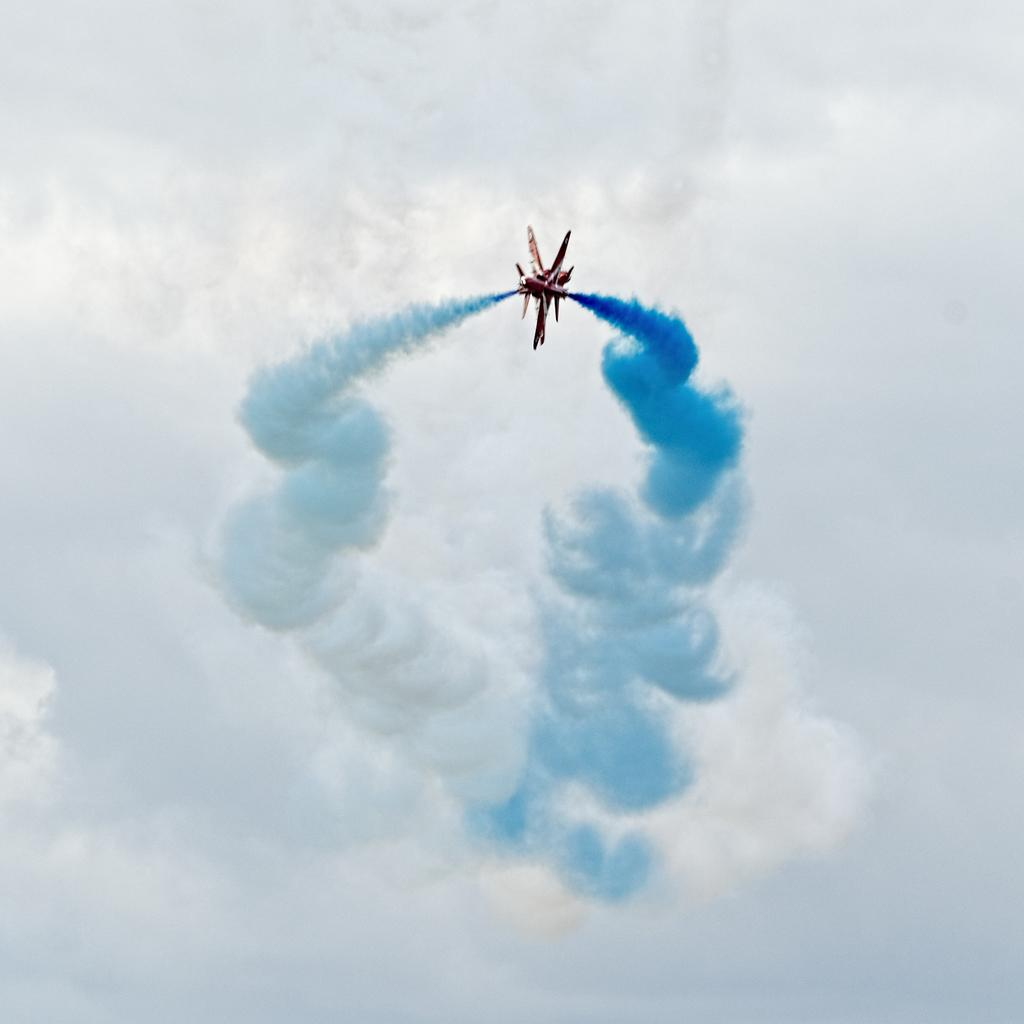What is the main subject of the image? The main subject of the image is a flight. What is the flight doing in the image? The flight is exhaling smoke. What color is the smoke being exhaled by the flight? The smoke is blue in color. What can be seen in the background of the image? There is a sky visible in the background of the image. What is present in the sky? Clouds are present in the sky. What type of toy can be seen in the hands of the doctor in the image? There is no doctor or toy present in the image; it features a flight exhaling blue smoke against a sky with clouds. 